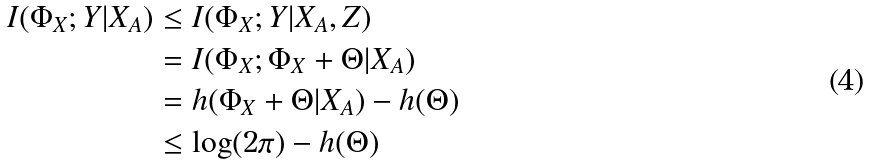Convert formula to latex. <formula><loc_0><loc_0><loc_500><loc_500>I ( \Phi _ { X } ; Y | X _ { A } ) & \leq I ( \Phi _ { X } ; Y | X _ { A } , Z ) \\ & = I ( \Phi _ { X } ; \Phi _ { X } + \Theta | X _ { A } ) \\ & = h ( \Phi _ { X } + \Theta | X _ { A } ) - h ( \Theta ) \\ & \leq \log ( 2 \pi ) - h ( \Theta )</formula> 